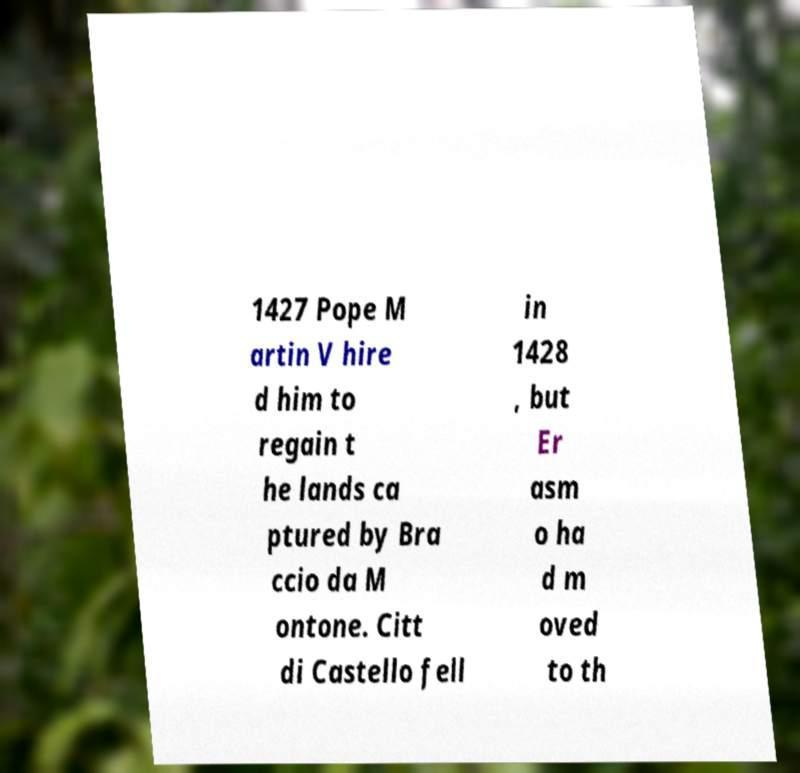I need the written content from this picture converted into text. Can you do that? 1427 Pope M artin V hire d him to regain t he lands ca ptured by Bra ccio da M ontone. Citt di Castello fell in 1428 , but Er asm o ha d m oved to th 